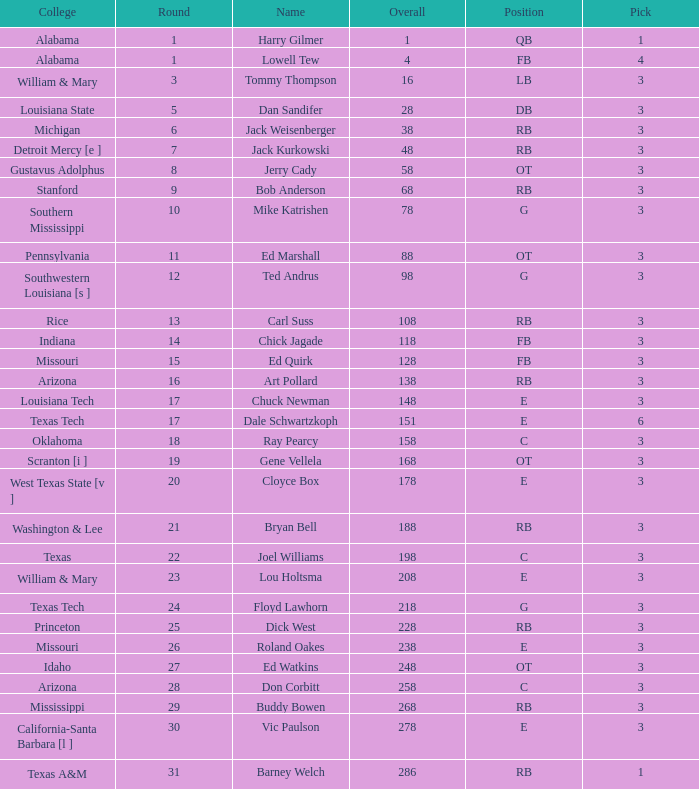Which Overall has a Name of bob anderson, and a Round smaller than 9? None. 